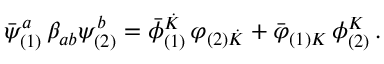Convert formula to latex. <formula><loc_0><loc_0><loc_500><loc_500>{ { \bar { \psi } } _ { ( 1 ) } ^ { a } } \, \beta _ { a b } \psi _ { ( 2 ) } ^ { b } = { { \bar { \phi } } _ { ( 1 ) } ^ { \dot { K } } } \, \varphi _ { ( 2 ) { \dot { K } } } + { { \bar { \varphi } } _ { ( 1 ) K } } \, \phi _ { ( 2 ) } ^ { K } \, .</formula> 